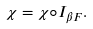Convert formula to latex. <formula><loc_0><loc_0><loc_500><loc_500>\chi = \chi \circ I _ { \beta F } .</formula> 